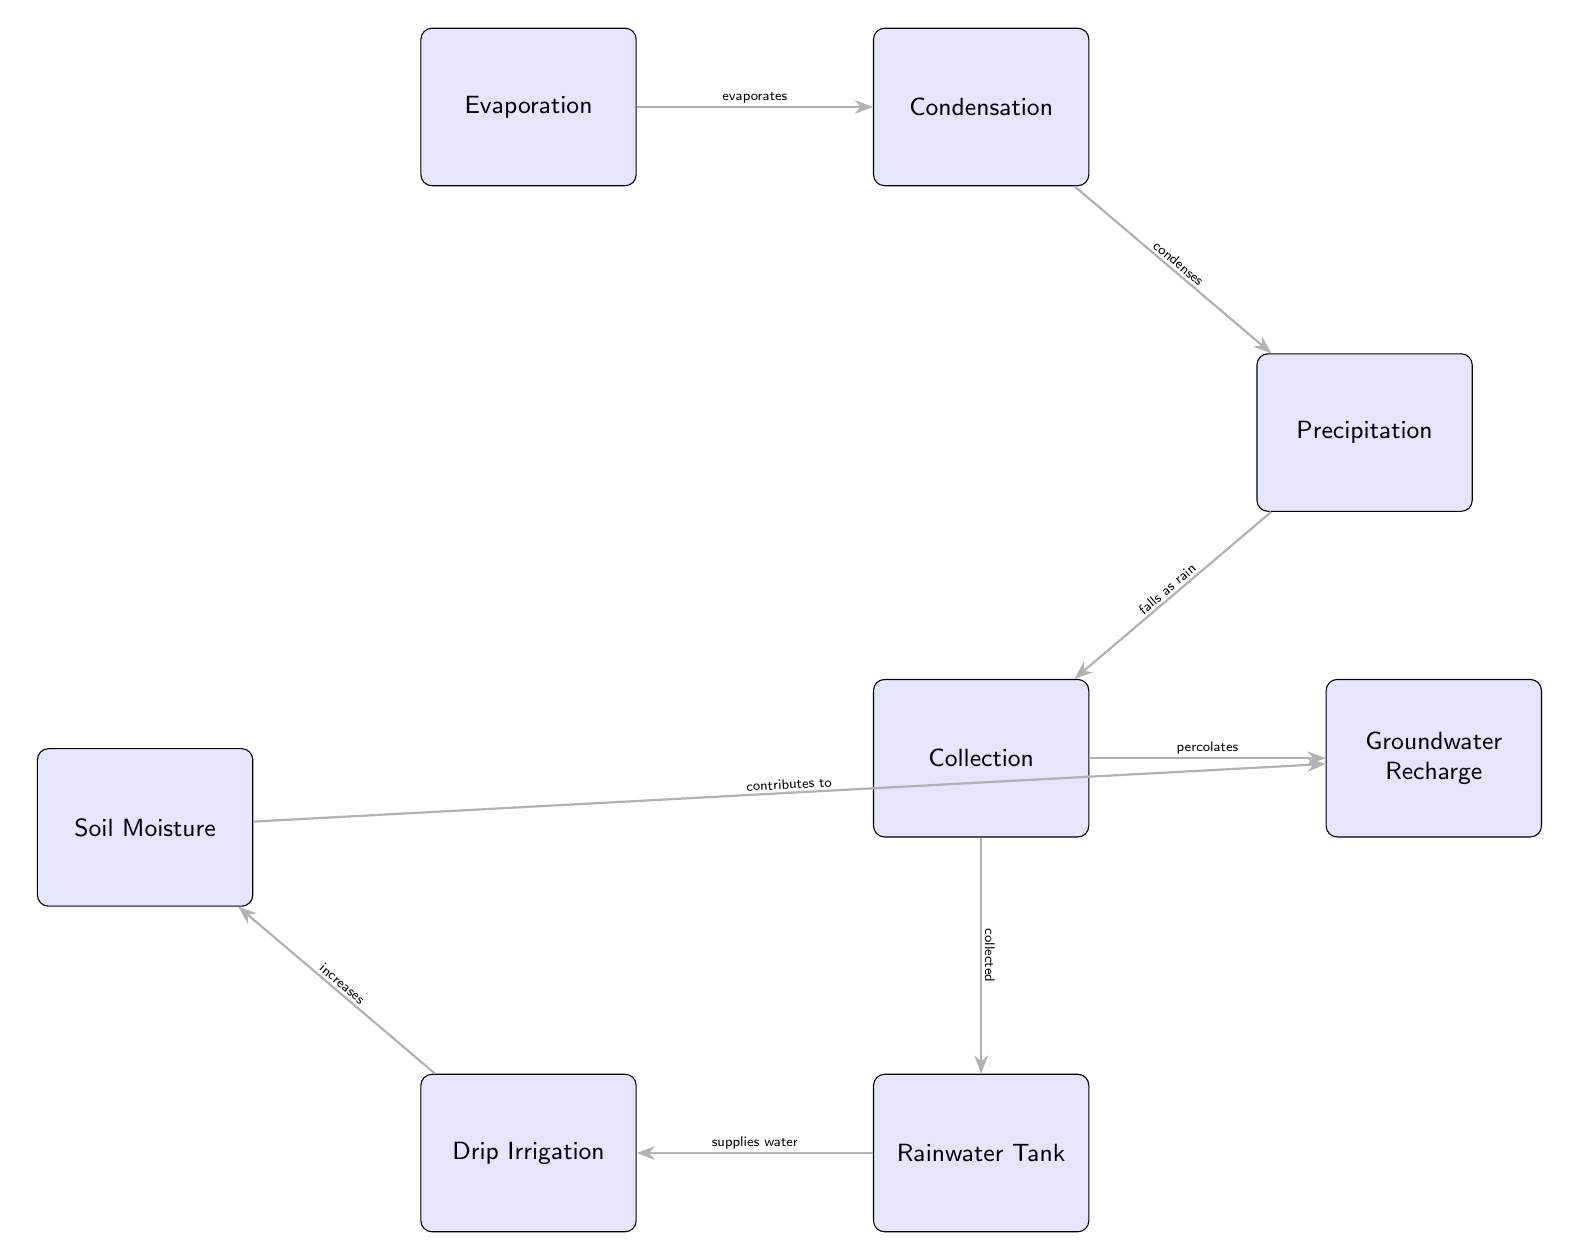What is the first step in the water cycle depicted in the diagram? The diagram starts with the "Evaporation" node, indicating that evaporation is the first step in the water cycle.
Answer: Evaporation How many main processes of the water cycle are shown in the diagram? There are four main processes represented: Evaporation, Condensation, Precipitation, and Collection.
Answer: Four What process occurs after precipitation in the diagram? Following precipitation, the next process shown is "Collection," where water is gathered.
Answer: Collection Which node indicates the collection of rainwater? The "Rainwater Tank" node indicates where collected rainwater is stored.
Answer: Rainwater Tank What contribution does soil moisture make in relation to groundwater? The diagram shows that "Soil Moisture" contributes to "Groundwater Recharge," indicating a beneficial relationship.
Answer: Contributes to Describe the relationship between collection and the rainwater tank. "Collection" is directly connected to the "Rainwater Tank" through a flow indicating that the collected water is stored in the tank.
Answer: Collected What type of irrigation method is supplied by the rainwater tank? The diagram specifies that "Drip Irrigation" is supplied with water from the rainwater tank.
Answer: Drip Irrigation How does the process of condensation affect precipitation? Condensation is depicted as leading to precipitation, as the water vapor condenses into droplets that fall as rain.
Answer: Condenses What is the role of drip irrigation in relation to soil moisture? The diagram indicates that drip irrigation increases soil moisture, showing its importance in sustainable farming practices.
Answer: Increases 